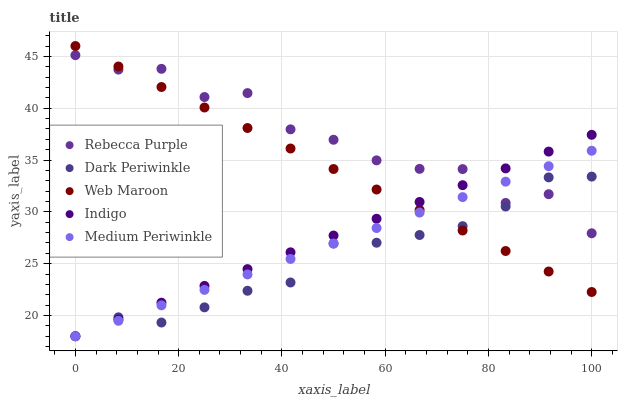Does Dark Periwinkle have the minimum area under the curve?
Answer yes or no. Yes. Does Rebecca Purple have the maximum area under the curve?
Answer yes or no. Yes. Does Web Maroon have the minimum area under the curve?
Answer yes or no. No. Does Web Maroon have the maximum area under the curve?
Answer yes or no. No. Is Indigo the smoothest?
Answer yes or no. Yes. Is Rebecca Purple the roughest?
Answer yes or no. Yes. Is Web Maroon the smoothest?
Answer yes or no. No. Is Web Maroon the roughest?
Answer yes or no. No. Does Indigo have the lowest value?
Answer yes or no. Yes. Does Web Maroon have the lowest value?
Answer yes or no. No. Does Web Maroon have the highest value?
Answer yes or no. Yes. Does Rebecca Purple have the highest value?
Answer yes or no. No. Does Dark Periwinkle intersect Web Maroon?
Answer yes or no. Yes. Is Dark Periwinkle less than Web Maroon?
Answer yes or no. No. Is Dark Periwinkle greater than Web Maroon?
Answer yes or no. No. 